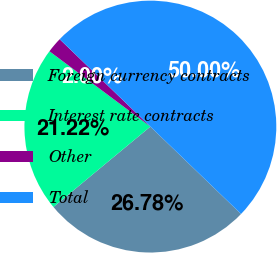Convert chart. <chart><loc_0><loc_0><loc_500><loc_500><pie_chart><fcel>Foreign currency contracts<fcel>Interest rate contracts<fcel>Other<fcel>Total<nl><fcel>26.78%<fcel>21.22%<fcel>2.0%<fcel>50.0%<nl></chart> 